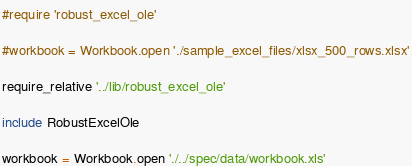Convert code to text. <code><loc_0><loc_0><loc_500><loc_500><_Ruby_>#require 'robust_excel_ole'

#workbook = Workbook.open './sample_excel_files/xlsx_500_rows.xlsx'

require_relative '../lib/robust_excel_ole'

include RobustExcelOle

workbook = Workbook.open './../spec/data/workbook.xls'
</code> 